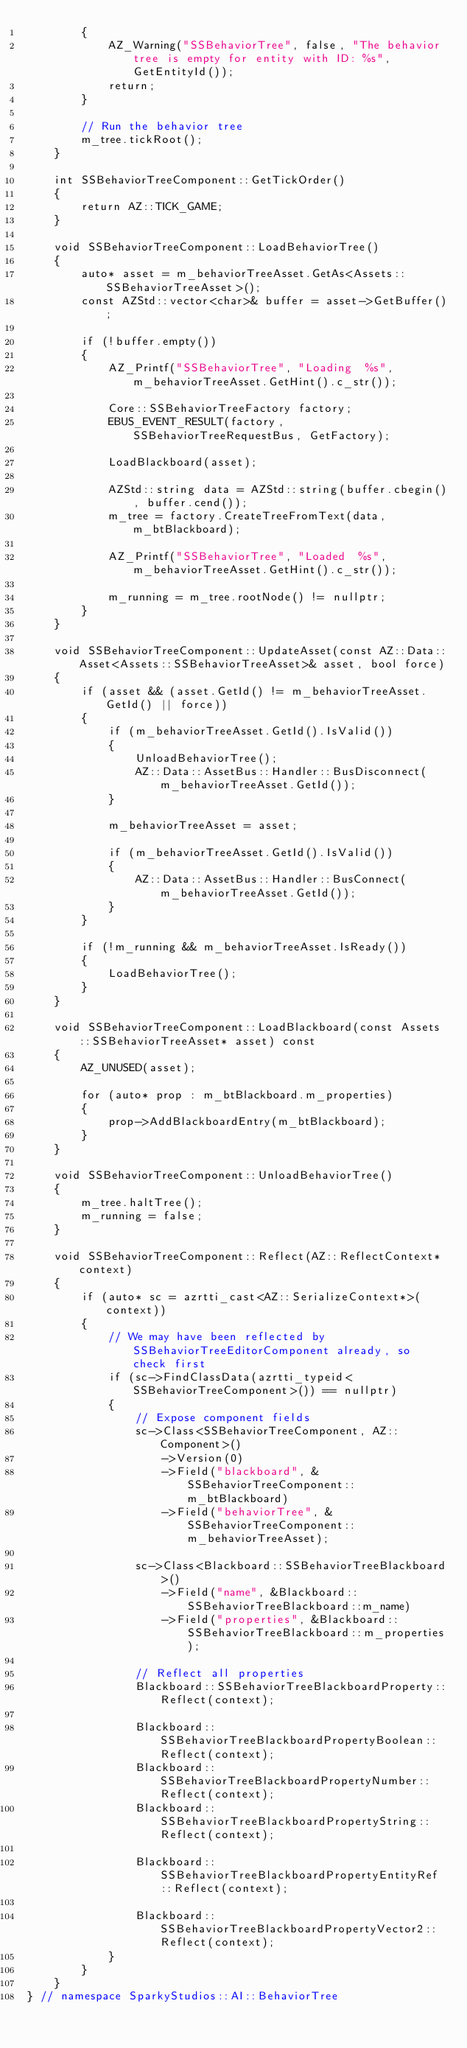<code> <loc_0><loc_0><loc_500><loc_500><_C++_>        {
            AZ_Warning("SSBehaviorTree", false, "The behavior tree is empty for entity with ID: %s", GetEntityId());
            return;
        }

        // Run the behavior tree
        m_tree.tickRoot();
    }

    int SSBehaviorTreeComponent::GetTickOrder()
    {
        return AZ::TICK_GAME;
    }

    void SSBehaviorTreeComponent::LoadBehaviorTree()
    {
        auto* asset = m_behaviorTreeAsset.GetAs<Assets::SSBehaviorTreeAsset>();
        const AZStd::vector<char>& buffer = asset->GetBuffer();

        if (!buffer.empty())
        {
            AZ_Printf("SSBehaviorTree", "Loading  %s", m_behaviorTreeAsset.GetHint().c_str());

            Core::SSBehaviorTreeFactory factory;
            EBUS_EVENT_RESULT(factory, SSBehaviorTreeRequestBus, GetFactory);

            LoadBlackboard(asset);

            AZStd::string data = AZStd::string(buffer.cbegin(), buffer.cend());
            m_tree = factory.CreateTreeFromText(data, m_btBlackboard);

            AZ_Printf("SSBehaviorTree", "Loaded  %s", m_behaviorTreeAsset.GetHint().c_str());

            m_running = m_tree.rootNode() != nullptr;
        }
    }

    void SSBehaviorTreeComponent::UpdateAsset(const AZ::Data::Asset<Assets::SSBehaviorTreeAsset>& asset, bool force)
    {
        if (asset && (asset.GetId() != m_behaviorTreeAsset.GetId() || force))
        {
            if (m_behaviorTreeAsset.GetId().IsValid())
            {
                UnloadBehaviorTree();
                AZ::Data::AssetBus::Handler::BusDisconnect(m_behaviorTreeAsset.GetId());
            }

            m_behaviorTreeAsset = asset;

            if (m_behaviorTreeAsset.GetId().IsValid())
            {
                AZ::Data::AssetBus::Handler::BusConnect(m_behaviorTreeAsset.GetId());
            }
        }

        if (!m_running && m_behaviorTreeAsset.IsReady())
        {
            LoadBehaviorTree();
        }
    }

    void SSBehaviorTreeComponent::LoadBlackboard(const Assets::SSBehaviorTreeAsset* asset) const
    {
        AZ_UNUSED(asset);

        for (auto* prop : m_btBlackboard.m_properties)
        {
            prop->AddBlackboardEntry(m_btBlackboard);
        }
    }

    void SSBehaviorTreeComponent::UnloadBehaviorTree()
    {
        m_tree.haltTree();
        m_running = false;
    }

    void SSBehaviorTreeComponent::Reflect(AZ::ReflectContext* context)
    {
        if (auto* sc = azrtti_cast<AZ::SerializeContext*>(context))
        {
            // We may have been reflected by SSBehaviorTreeEditorComponent already, so check first
            if (sc->FindClassData(azrtti_typeid<SSBehaviorTreeComponent>()) == nullptr)
            {
                // Expose component fields
                sc->Class<SSBehaviorTreeComponent, AZ::Component>()
                    ->Version(0)
                    ->Field("blackboard", &SSBehaviorTreeComponent::m_btBlackboard)
                    ->Field("behaviorTree", &SSBehaviorTreeComponent::m_behaviorTreeAsset);

                sc->Class<Blackboard::SSBehaviorTreeBlackboard>()
                    ->Field("name", &Blackboard::SSBehaviorTreeBlackboard::m_name)
                    ->Field("properties", &Blackboard::SSBehaviorTreeBlackboard::m_properties);

                // Reflect all properties
                Blackboard::SSBehaviorTreeBlackboardProperty::Reflect(context);

                Blackboard::SSBehaviorTreeBlackboardPropertyBoolean::Reflect(context);
                Blackboard::SSBehaviorTreeBlackboardPropertyNumber::Reflect(context);
                Blackboard::SSBehaviorTreeBlackboardPropertyString::Reflect(context);

                Blackboard::SSBehaviorTreeBlackboardPropertyEntityRef::Reflect(context);

                Blackboard::SSBehaviorTreeBlackboardPropertyVector2::Reflect(context);
            }
        }
    }
} // namespace SparkyStudios::AI::BehaviorTree
</code> 